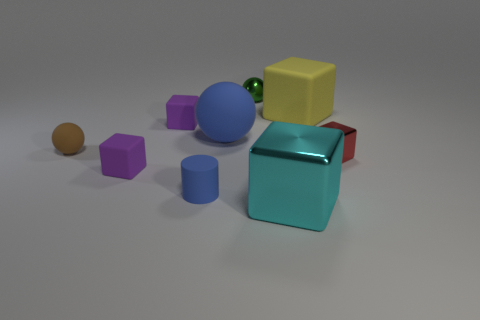Is the color of the tiny rubber cylinder the same as the small matte ball?
Your answer should be very brief. No. Is the shape of the large matte thing that is right of the cyan cube the same as  the big blue thing?
Provide a succinct answer. No. How many blocks are right of the big rubber sphere and behind the cyan metallic cube?
Provide a short and direct response. 2. What is the material of the small brown object?
Your answer should be very brief. Rubber. Are there any other things that are the same color as the big metallic cube?
Your answer should be compact. No. Do the large yellow object and the big blue thing have the same material?
Your response must be concise. Yes. There is a metal thing right of the large block that is behind the tiny blue thing; what number of shiny spheres are to the right of it?
Keep it short and to the point. 0. How many tiny brown cylinders are there?
Your answer should be very brief. 0. Are there fewer large blue rubber spheres in front of the yellow matte cube than small rubber cylinders that are behind the big cyan thing?
Offer a terse response. No. Is the number of small brown balls that are in front of the small blue cylinder less than the number of things?
Provide a short and direct response. Yes. 